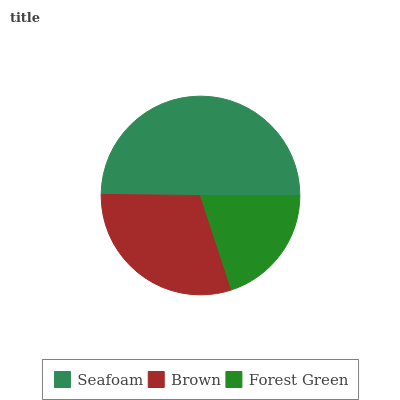Is Forest Green the minimum?
Answer yes or no. Yes. Is Seafoam the maximum?
Answer yes or no. Yes. Is Brown the minimum?
Answer yes or no. No. Is Brown the maximum?
Answer yes or no. No. Is Seafoam greater than Brown?
Answer yes or no. Yes. Is Brown less than Seafoam?
Answer yes or no. Yes. Is Brown greater than Seafoam?
Answer yes or no. No. Is Seafoam less than Brown?
Answer yes or no. No. Is Brown the high median?
Answer yes or no. Yes. Is Brown the low median?
Answer yes or no. Yes. Is Seafoam the high median?
Answer yes or no. No. Is Seafoam the low median?
Answer yes or no. No. 